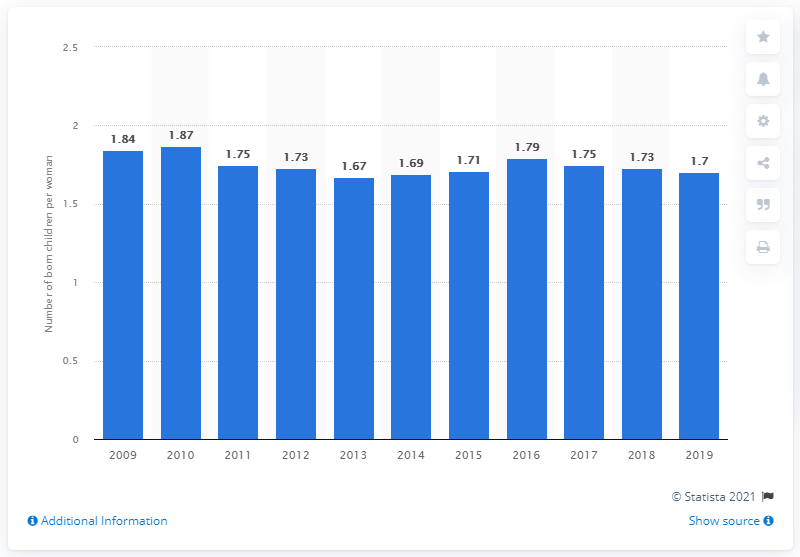Indicate a few pertinent items in this graphic. The fertility rate in Denmark in 2019 was 1.7. 